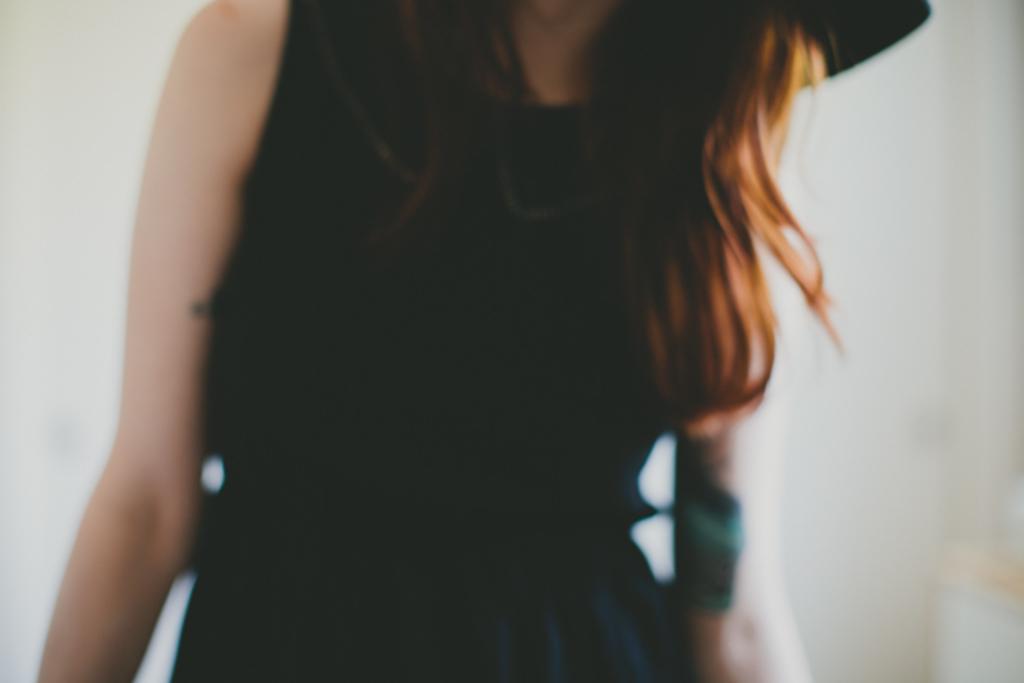Describe this image in one or two sentences. In this image we can see a woman wearing a black dress. 